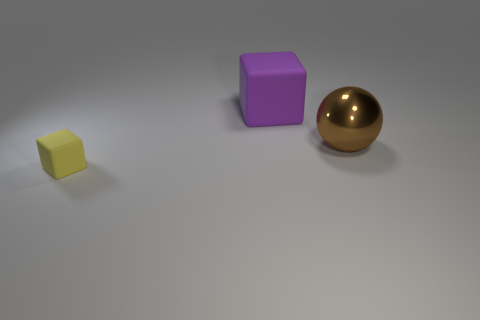How big is the cube that is behind the large brown thing to the right of the yellow object?
Give a very brief answer. Large. There is a thing that is behind the tiny rubber thing and in front of the purple rubber thing; what color is it?
Keep it short and to the point. Brown. What is the material of the other object that is the same size as the metallic object?
Offer a terse response. Rubber. What number of other objects are there of the same material as the tiny yellow object?
Your answer should be compact. 1. There is a matte cube that is behind the big shiny object; does it have the same color as the rubber thing in front of the large purple cube?
Your answer should be compact. No. What is the shape of the matte thing that is in front of the rubber thing on the right side of the small matte object?
Offer a very short reply. Cube. What number of other things are the same color as the large sphere?
Offer a very short reply. 0. Do the thing that is to the right of the purple rubber block and the big thing that is behind the big metal object have the same material?
Offer a very short reply. No. What size is the rubber thing right of the small yellow matte block?
Ensure brevity in your answer.  Large. There is a tiny yellow object that is the same shape as the large matte object; what is it made of?
Your answer should be compact. Rubber. 